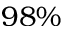Convert formula to latex. <formula><loc_0><loc_0><loc_500><loc_500>9 8 \%</formula> 